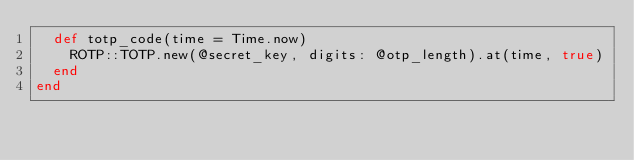Convert code to text. <code><loc_0><loc_0><loc_500><loc_500><_Ruby_>  def totp_code(time = Time.now)
    ROTP::TOTP.new(@secret_key, digits: @otp_length).at(time, true)
  end
end
</code> 